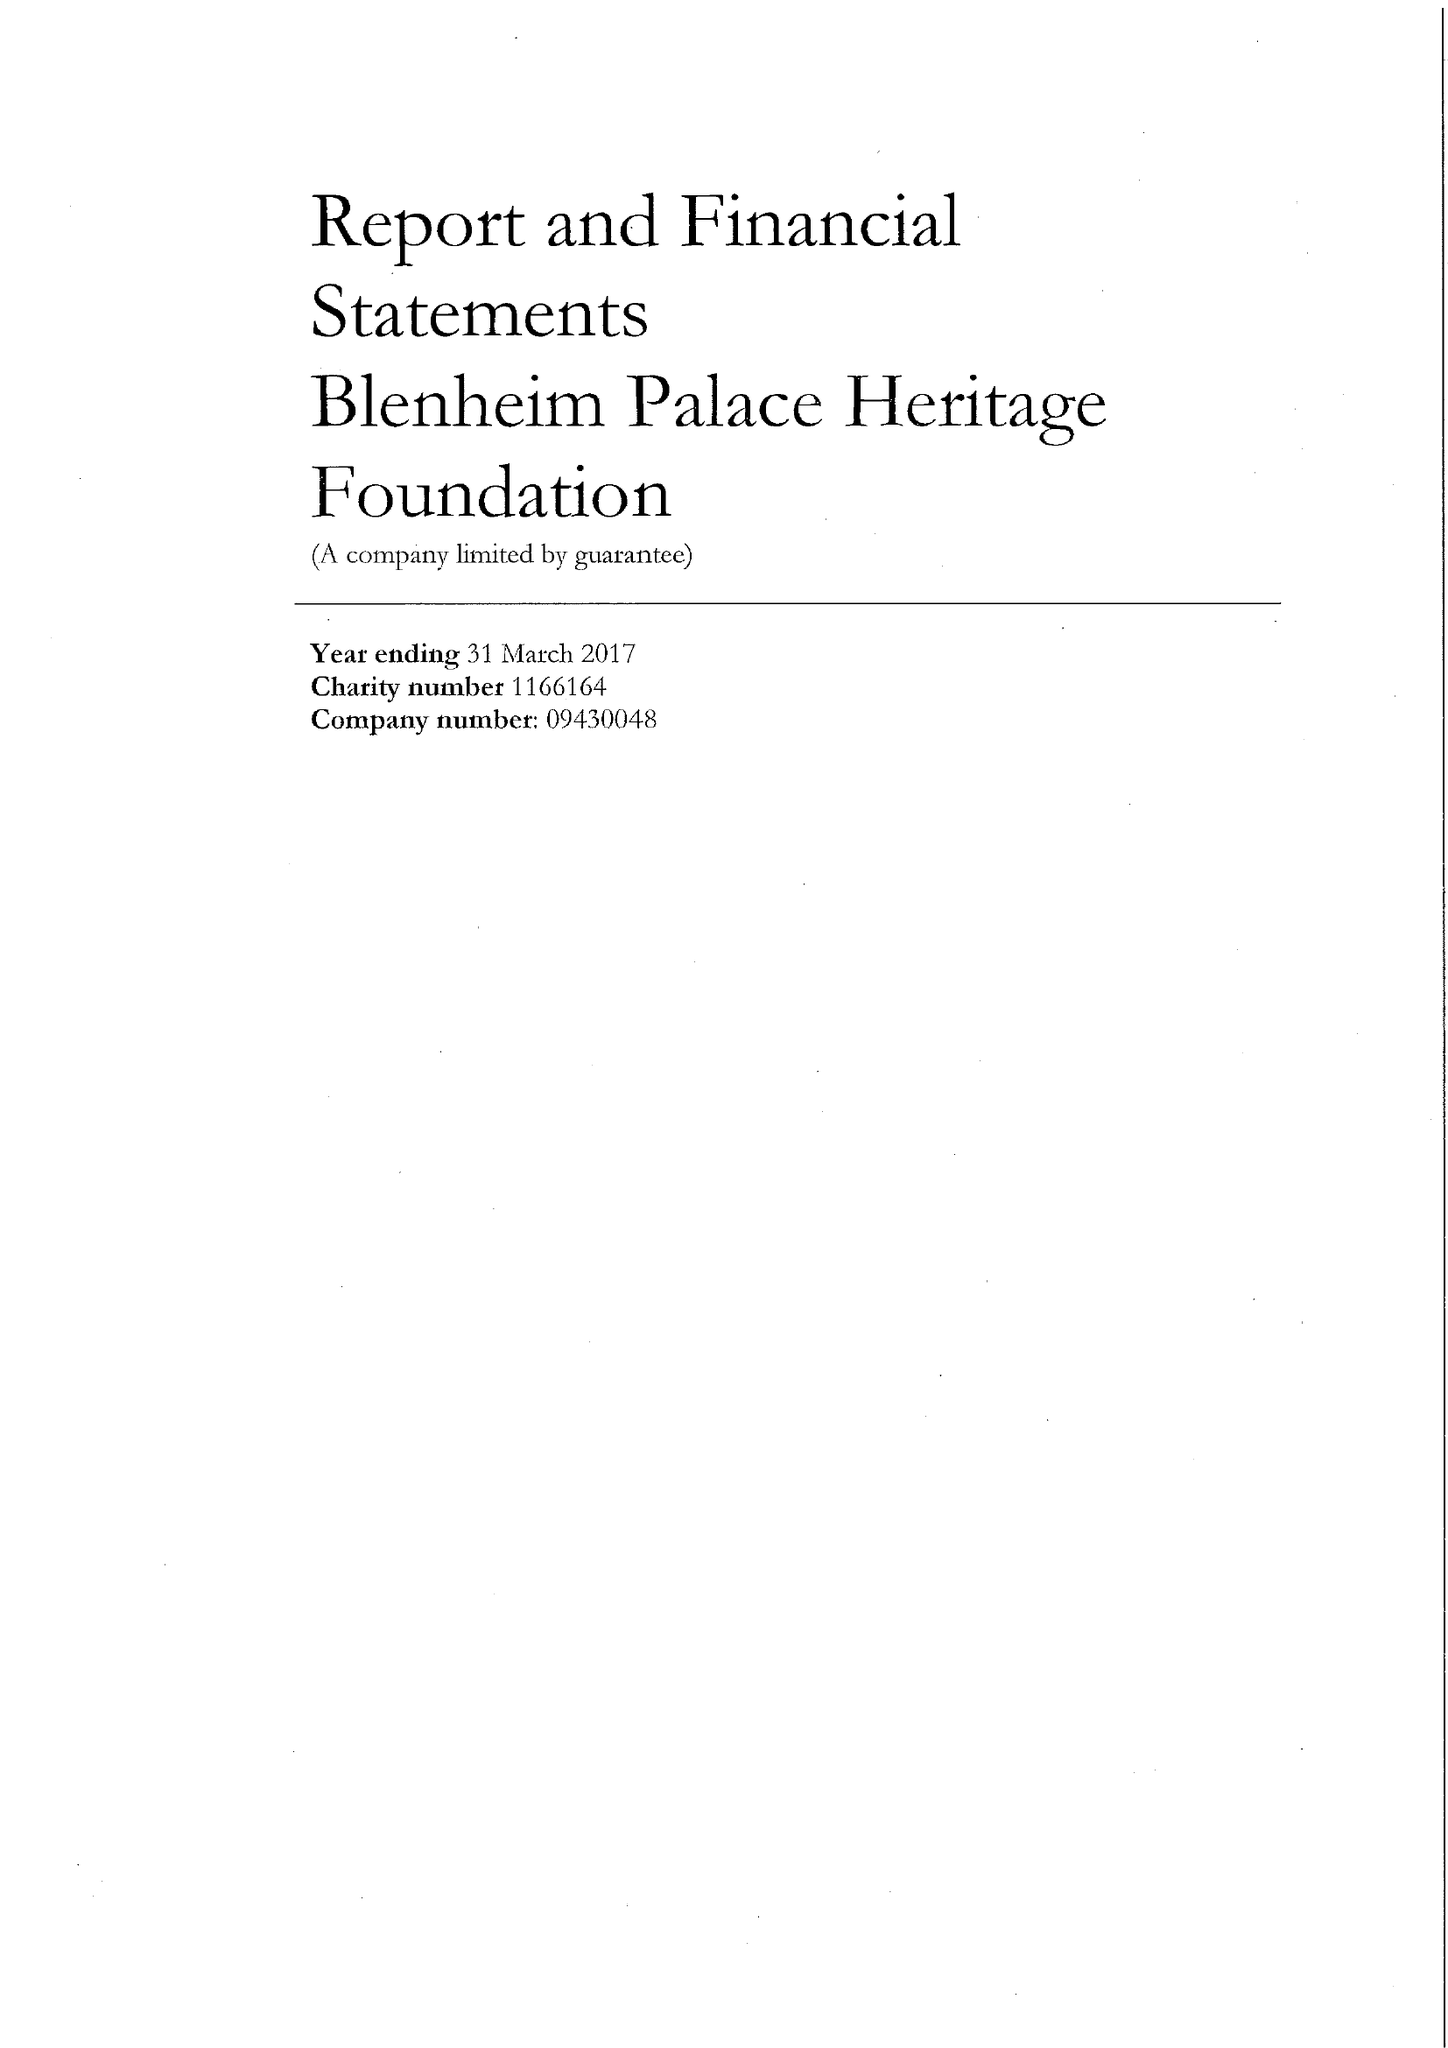What is the value for the address__post_town?
Answer the question using a single word or phrase. WOODSTOCK 